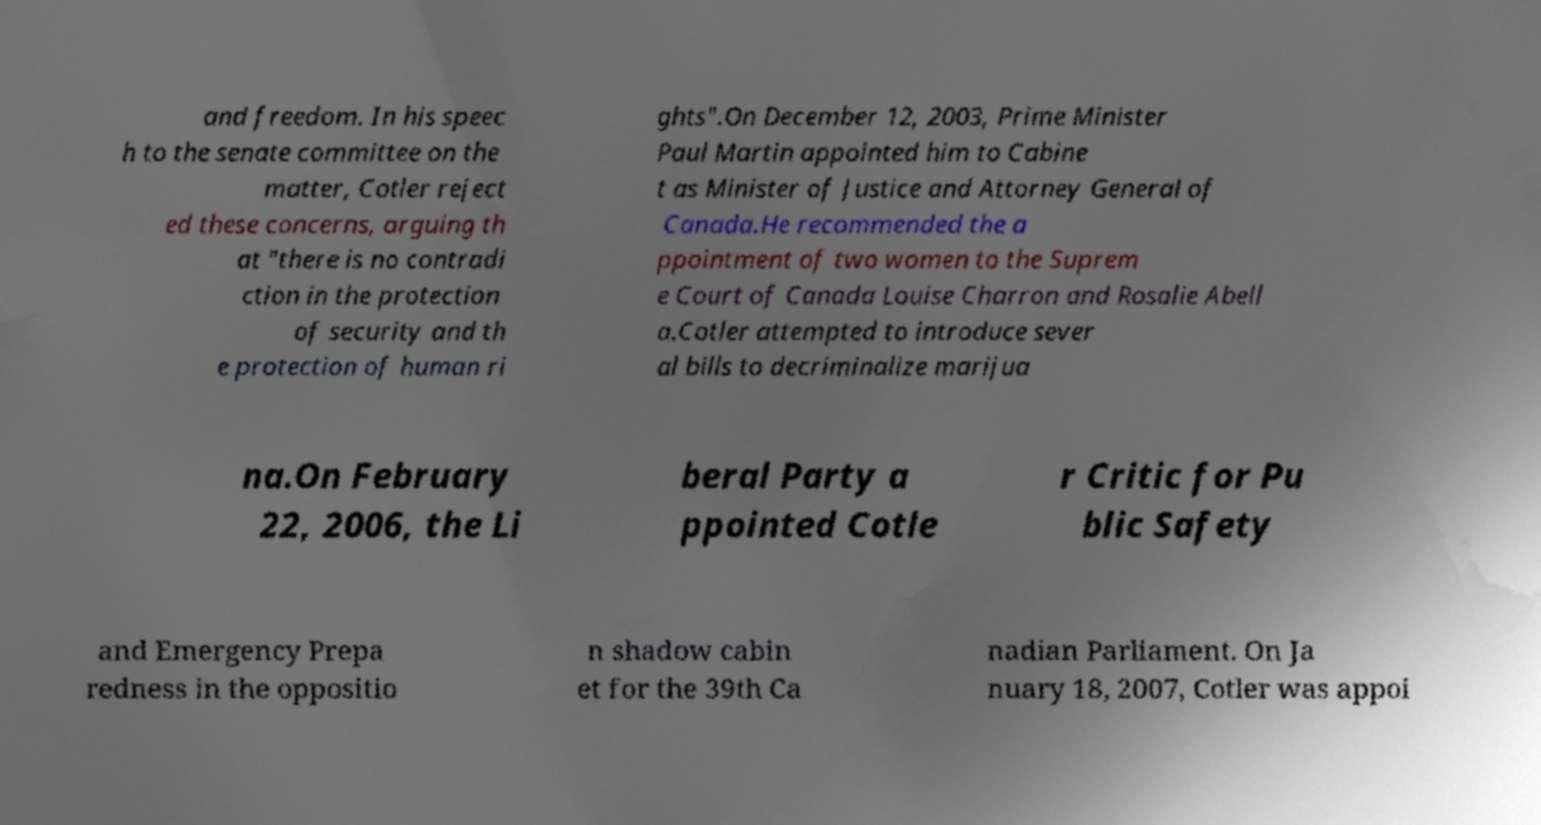Could you assist in decoding the text presented in this image and type it out clearly? and freedom. In his speec h to the senate committee on the matter, Cotler reject ed these concerns, arguing th at "there is no contradi ction in the protection of security and th e protection of human ri ghts".On December 12, 2003, Prime Minister Paul Martin appointed him to Cabine t as Minister of Justice and Attorney General of Canada.He recommended the a ppointment of two women to the Suprem e Court of Canada Louise Charron and Rosalie Abell a.Cotler attempted to introduce sever al bills to decriminalize marijua na.On February 22, 2006, the Li beral Party a ppointed Cotle r Critic for Pu blic Safety and Emergency Prepa redness in the oppositio n shadow cabin et for the 39th Ca nadian Parliament. On Ja nuary 18, 2007, Cotler was appoi 